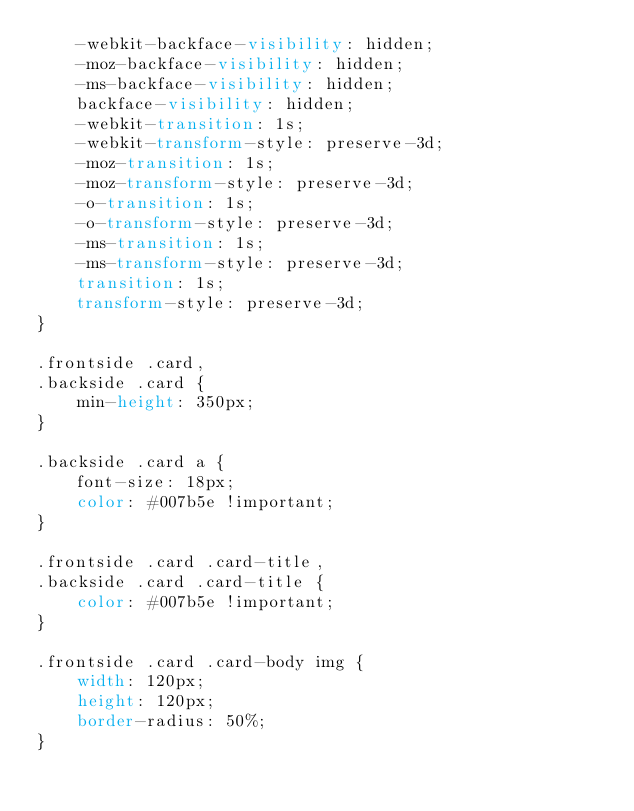<code> <loc_0><loc_0><loc_500><loc_500><_CSS_>    -webkit-backface-visibility: hidden;
    -moz-backface-visibility: hidden;
    -ms-backface-visibility: hidden;
    backface-visibility: hidden;
    -webkit-transition: 1s;
    -webkit-transform-style: preserve-3d;
    -moz-transition: 1s;
    -moz-transform-style: preserve-3d;
    -o-transition: 1s;
    -o-transform-style: preserve-3d;
    -ms-transition: 1s;
    -ms-transform-style: preserve-3d;
    transition: 1s;
    transform-style: preserve-3d;
}

.frontside .card,
.backside .card {
    min-height: 350px;
}

.backside .card a {
    font-size: 18px;
    color: #007b5e !important;
}

.frontside .card .card-title,
.backside .card .card-title {
    color: #007b5e !important;
}

.frontside .card .card-body img {
    width: 120px;
    height: 120px;
    border-radius: 50%;
}
</code> 